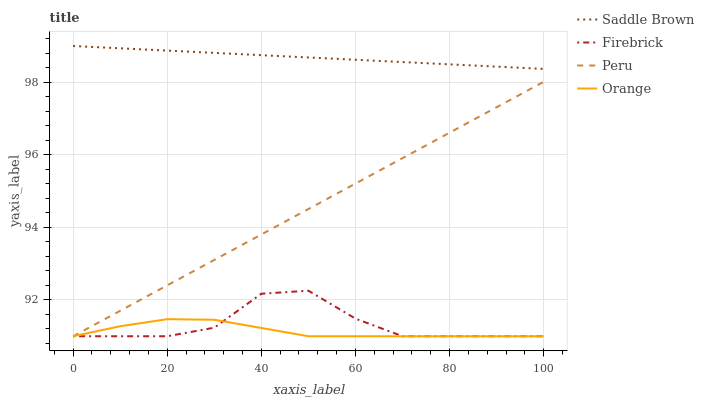Does Orange have the minimum area under the curve?
Answer yes or no. Yes. Does Saddle Brown have the maximum area under the curve?
Answer yes or no. Yes. Does Firebrick have the minimum area under the curve?
Answer yes or no. No. Does Firebrick have the maximum area under the curve?
Answer yes or no. No. Is Saddle Brown the smoothest?
Answer yes or no. Yes. Is Firebrick the roughest?
Answer yes or no. Yes. Is Firebrick the smoothest?
Answer yes or no. No. Is Saddle Brown the roughest?
Answer yes or no. No. Does Saddle Brown have the lowest value?
Answer yes or no. No. Does Firebrick have the highest value?
Answer yes or no. No. Is Firebrick less than Saddle Brown?
Answer yes or no. Yes. Is Saddle Brown greater than Orange?
Answer yes or no. Yes. Does Firebrick intersect Saddle Brown?
Answer yes or no. No. 